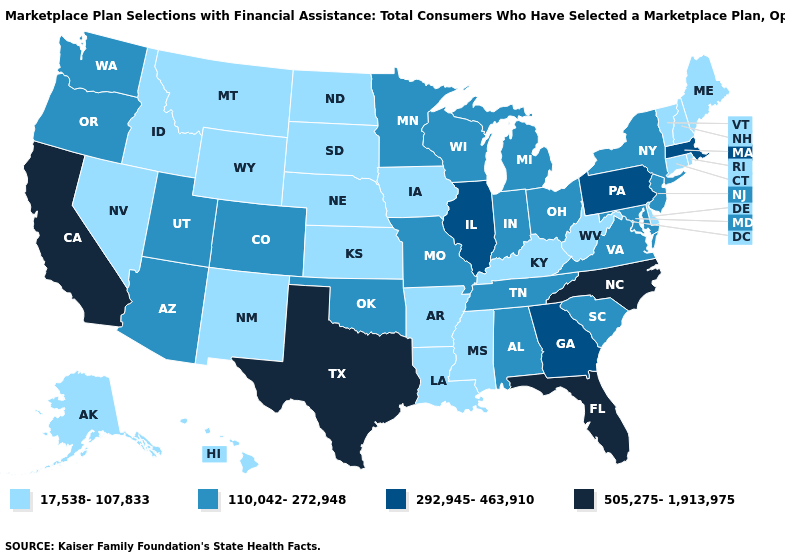Name the states that have a value in the range 505,275-1,913,975?
Be succinct. California, Florida, North Carolina, Texas. Does Wyoming have the lowest value in the USA?
Quick response, please. Yes. Among the states that border Kansas , does Oklahoma have the lowest value?
Answer briefly. No. What is the lowest value in the USA?
Write a very short answer. 17,538-107,833. Among the states that border Massachusetts , which have the lowest value?
Be succinct. Connecticut, New Hampshire, Rhode Island, Vermont. What is the lowest value in the USA?
Short answer required. 17,538-107,833. Does Alaska have the same value as Rhode Island?
Answer briefly. Yes. Does Arkansas have the lowest value in the USA?
Quick response, please. Yes. What is the value of Wisconsin?
Keep it brief. 110,042-272,948. Does the map have missing data?
Write a very short answer. No. What is the value of Arizona?
Write a very short answer. 110,042-272,948. Does Massachusetts have the lowest value in the USA?
Write a very short answer. No. What is the lowest value in the USA?
Concise answer only. 17,538-107,833. What is the highest value in the USA?
Keep it brief. 505,275-1,913,975. Name the states that have a value in the range 292,945-463,910?
Keep it brief. Georgia, Illinois, Massachusetts, Pennsylvania. 